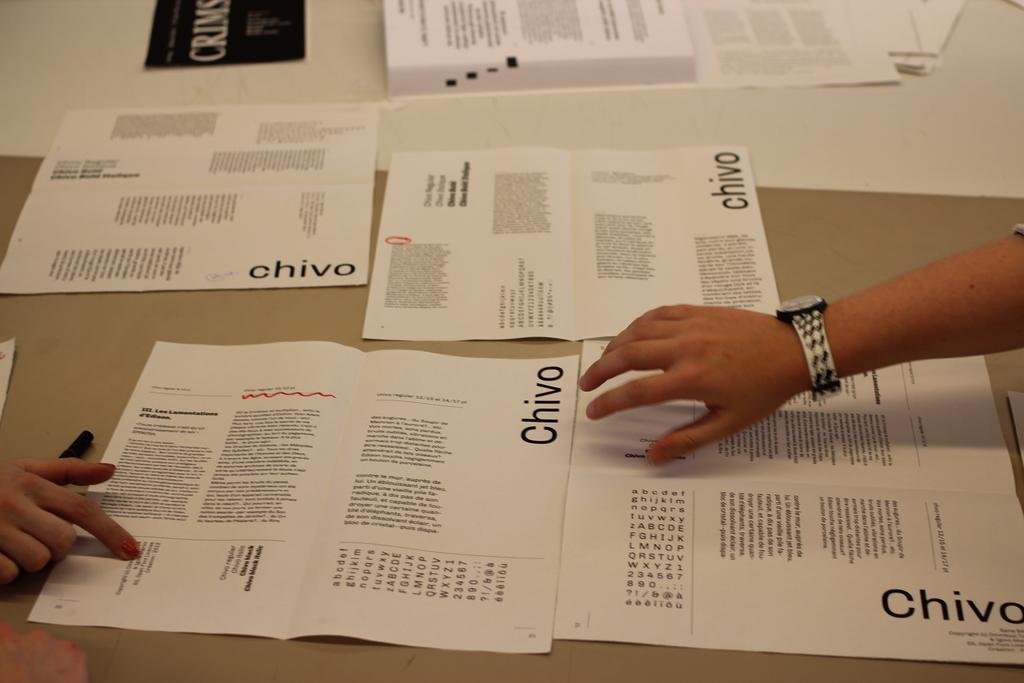Describe this image in one or two sentences. In this image we can see papers on the table. There are persons hands. 